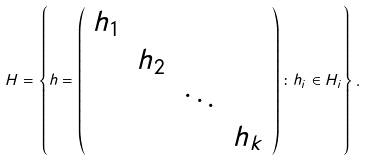Convert formula to latex. <formula><loc_0><loc_0><loc_500><loc_500>H = \left \{ h = \left ( \begin{array} { c c c c } h _ { 1 } & & & \\ & h _ { 2 } & & \\ & & \ddots & \\ & & & h _ { k } \end{array} \right ) \colon h _ { i } \in H _ { i } \right \} .</formula> 